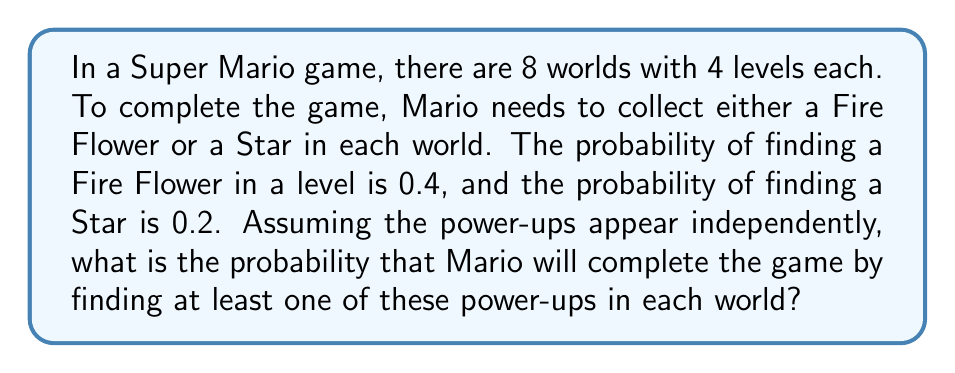What is the answer to this math problem? Let's approach this step-by-step:

1) First, we need to calculate the probability of finding at least one of the power-ups (Fire Flower or Star) in a single level:

   $P(\text{at least one power-up}) = 1 - P(\text{no power-up})$
   $= 1 - (1-0.4)(1-0.2) = 1 - 0.6 \times 0.8 = 1 - 0.48 = 0.52$

2) Now, we need to find the probability of not getting any power-up in all 4 levels of a world:

   $P(\text{no power-up in a world}) = (1-0.52)^4 = 0.48^4 \approx 0.0531$

3) Therefore, the probability of getting at least one power-up in a world is:

   $P(\text{at least one power-up in a world}) = 1 - 0.0531 = 0.9469$

4) To complete the game, Mario needs to get at least one power-up in each of the 8 worlds. This is equivalent to succeeding 8 independent times, each with probability 0.9469:

   $P(\text{completing the game}) = 0.9469^8 \approx 0.6509$

5) Converting to a percentage:

   $0.6509 \times 100\% \approx 65.09\%$
Answer: $65.09\%$ 